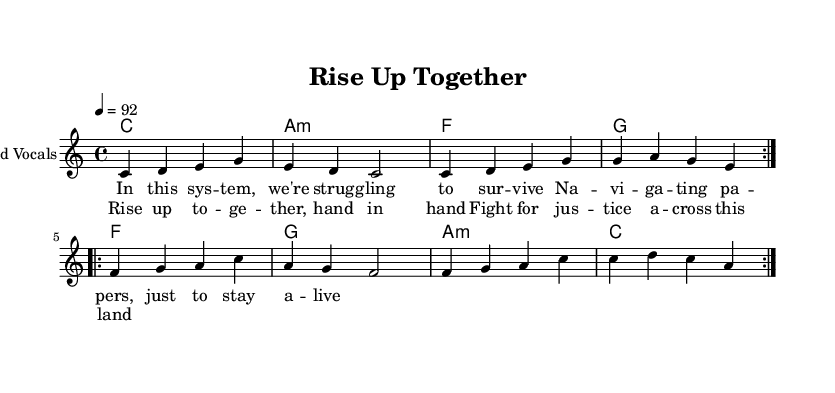What is the key signature of this music? The key signature of this piece is C major, which has no sharps or flats indicated in the music. This is determined by the presence of the absence of any accidental notes throughout the sheet music.
Answer: C major What is the time signature of the piece? The time signature is indicated at the beginning of the score as 4/4, meaning there are four beats per measure and the quarter note receives one beat. This is visible in the notation at the start of the sheet music.
Answer: 4/4 What is the tempo marking for this piece? The tempo marking is indicated as 92 BPM (beats per minute), which is seen written as "4 = 92" in the tempo section. This specifies how quickly the music should be played.
Answer: 92 How many measures are in the verses? The verse section has eight measures total, as seen from the two repeated sections each containing four measures that are outlined in the melody part of the sheet music.
Answer: Eight What chords are used in the chorus? The chorus chords are F, G, A minor, and C, as listed in the chord mode section below the vocal melody. These represent the harmony throughout the chorus.
Answer: F, G, A minor, C What is the overall theme of the lyrics? The lyrics focus on struggles related to social challenges and unity, as they depict the fight for justice and survival in a difficult system, capturing the essence of systemic inequality that the song addresses.
Answer: Social challenges and unity How many times is the melody repeated in the verse? The melody in the verse is repeated two times, as indicated by the notation "repeat volta 2" at the beginning of the verse section. This signifies that the melody should be played twice before moving on.
Answer: Two 